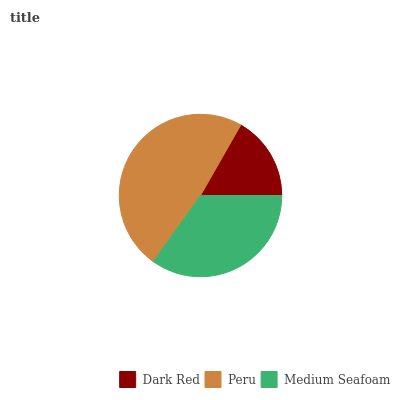Is Dark Red the minimum?
Answer yes or no. Yes. Is Peru the maximum?
Answer yes or no. Yes. Is Medium Seafoam the minimum?
Answer yes or no. No. Is Medium Seafoam the maximum?
Answer yes or no. No. Is Peru greater than Medium Seafoam?
Answer yes or no. Yes. Is Medium Seafoam less than Peru?
Answer yes or no. Yes. Is Medium Seafoam greater than Peru?
Answer yes or no. No. Is Peru less than Medium Seafoam?
Answer yes or no. No. Is Medium Seafoam the high median?
Answer yes or no. Yes. Is Medium Seafoam the low median?
Answer yes or no. Yes. Is Dark Red the high median?
Answer yes or no. No. Is Peru the low median?
Answer yes or no. No. 